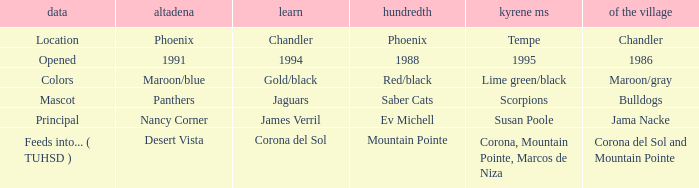Which Centennial has a del Pueblo of 1986? 1988.0. 